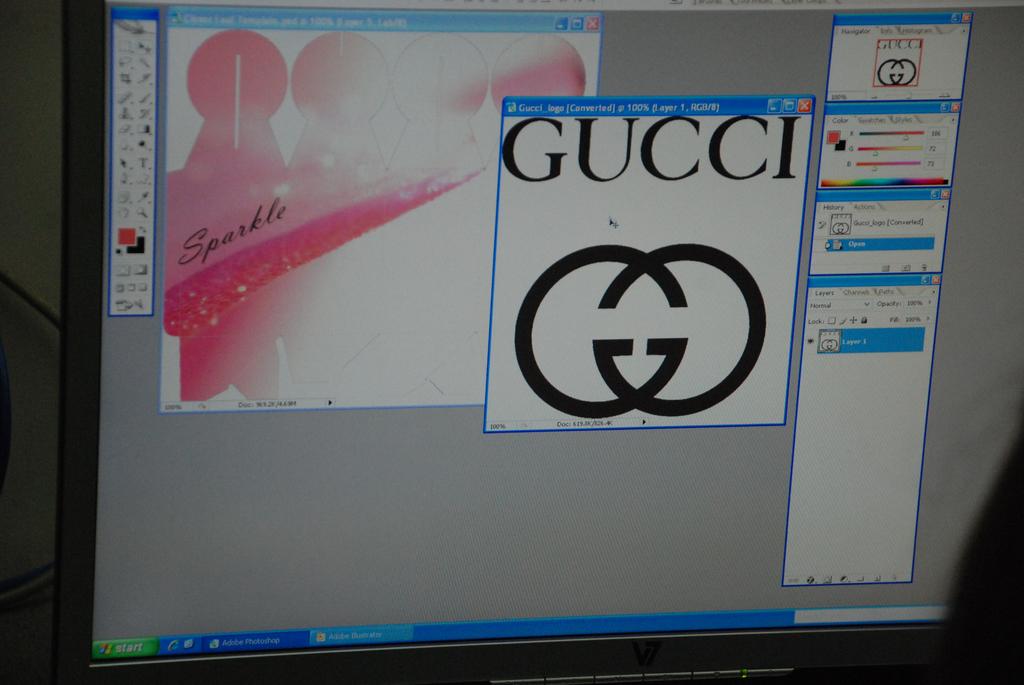What brand is on the computer?
Offer a terse response. Gucci. What brand is on the left side of the screen written in black over pink?
Keep it short and to the point. Sparkle. 